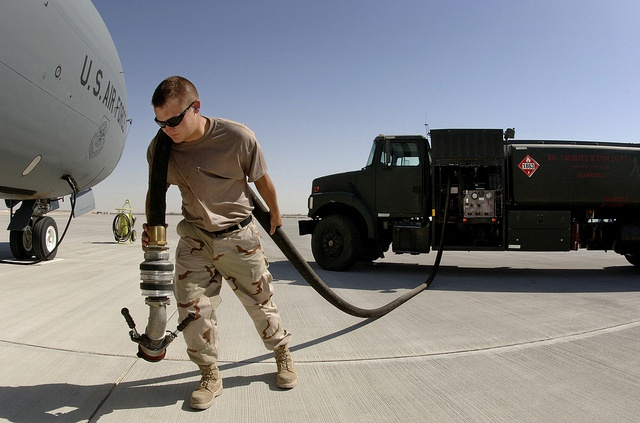Describe the objects in this image and their specific colors. I can see truck in gray, black, darkgray, and maroon tones, people in gray, maroon, and black tones, and airplane in gray and black tones in this image. 